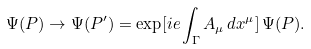Convert formula to latex. <formula><loc_0><loc_0><loc_500><loc_500>\Psi ( P ) \rightarrow \Psi ( P ^ { \prime } ) = \exp [ i e \int _ { \Gamma } A _ { \mu } \, d x ^ { \mu } ] \, \Psi ( P ) .</formula> 